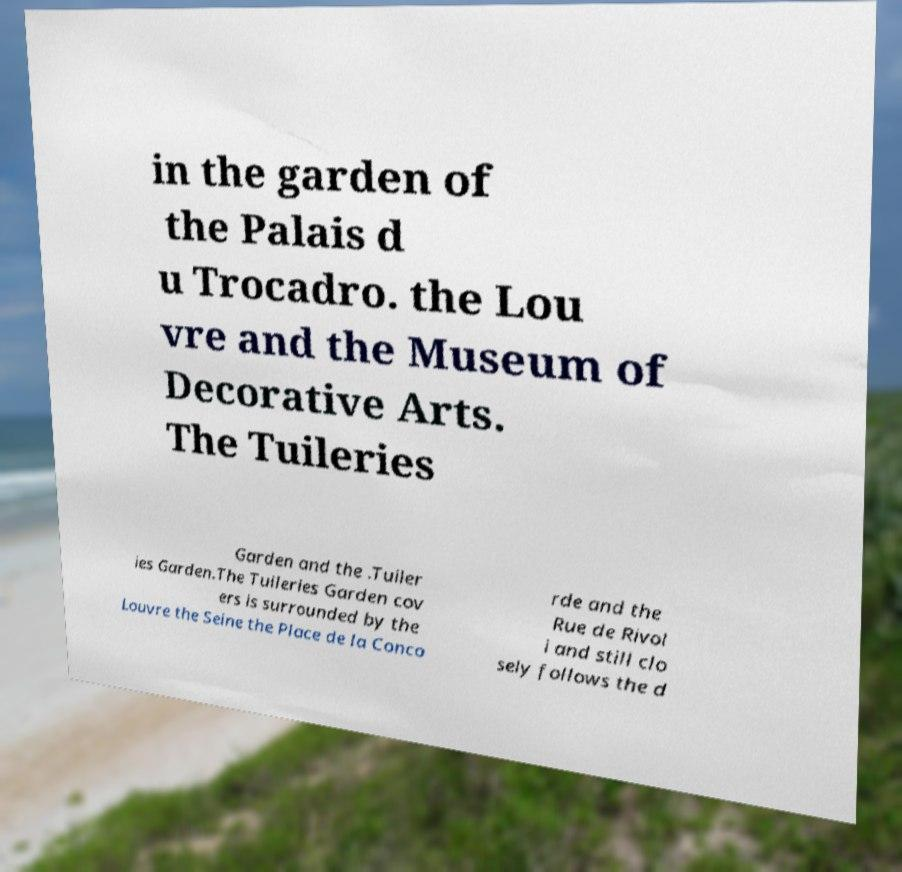For documentation purposes, I need the text within this image transcribed. Could you provide that? in the garden of the Palais d u Trocadro. the Lou vre and the Museum of Decorative Arts. The Tuileries Garden and the .Tuiler ies Garden.The Tuileries Garden cov ers is surrounded by the Louvre the Seine the Place de la Conco rde and the Rue de Rivol i and still clo sely follows the d 